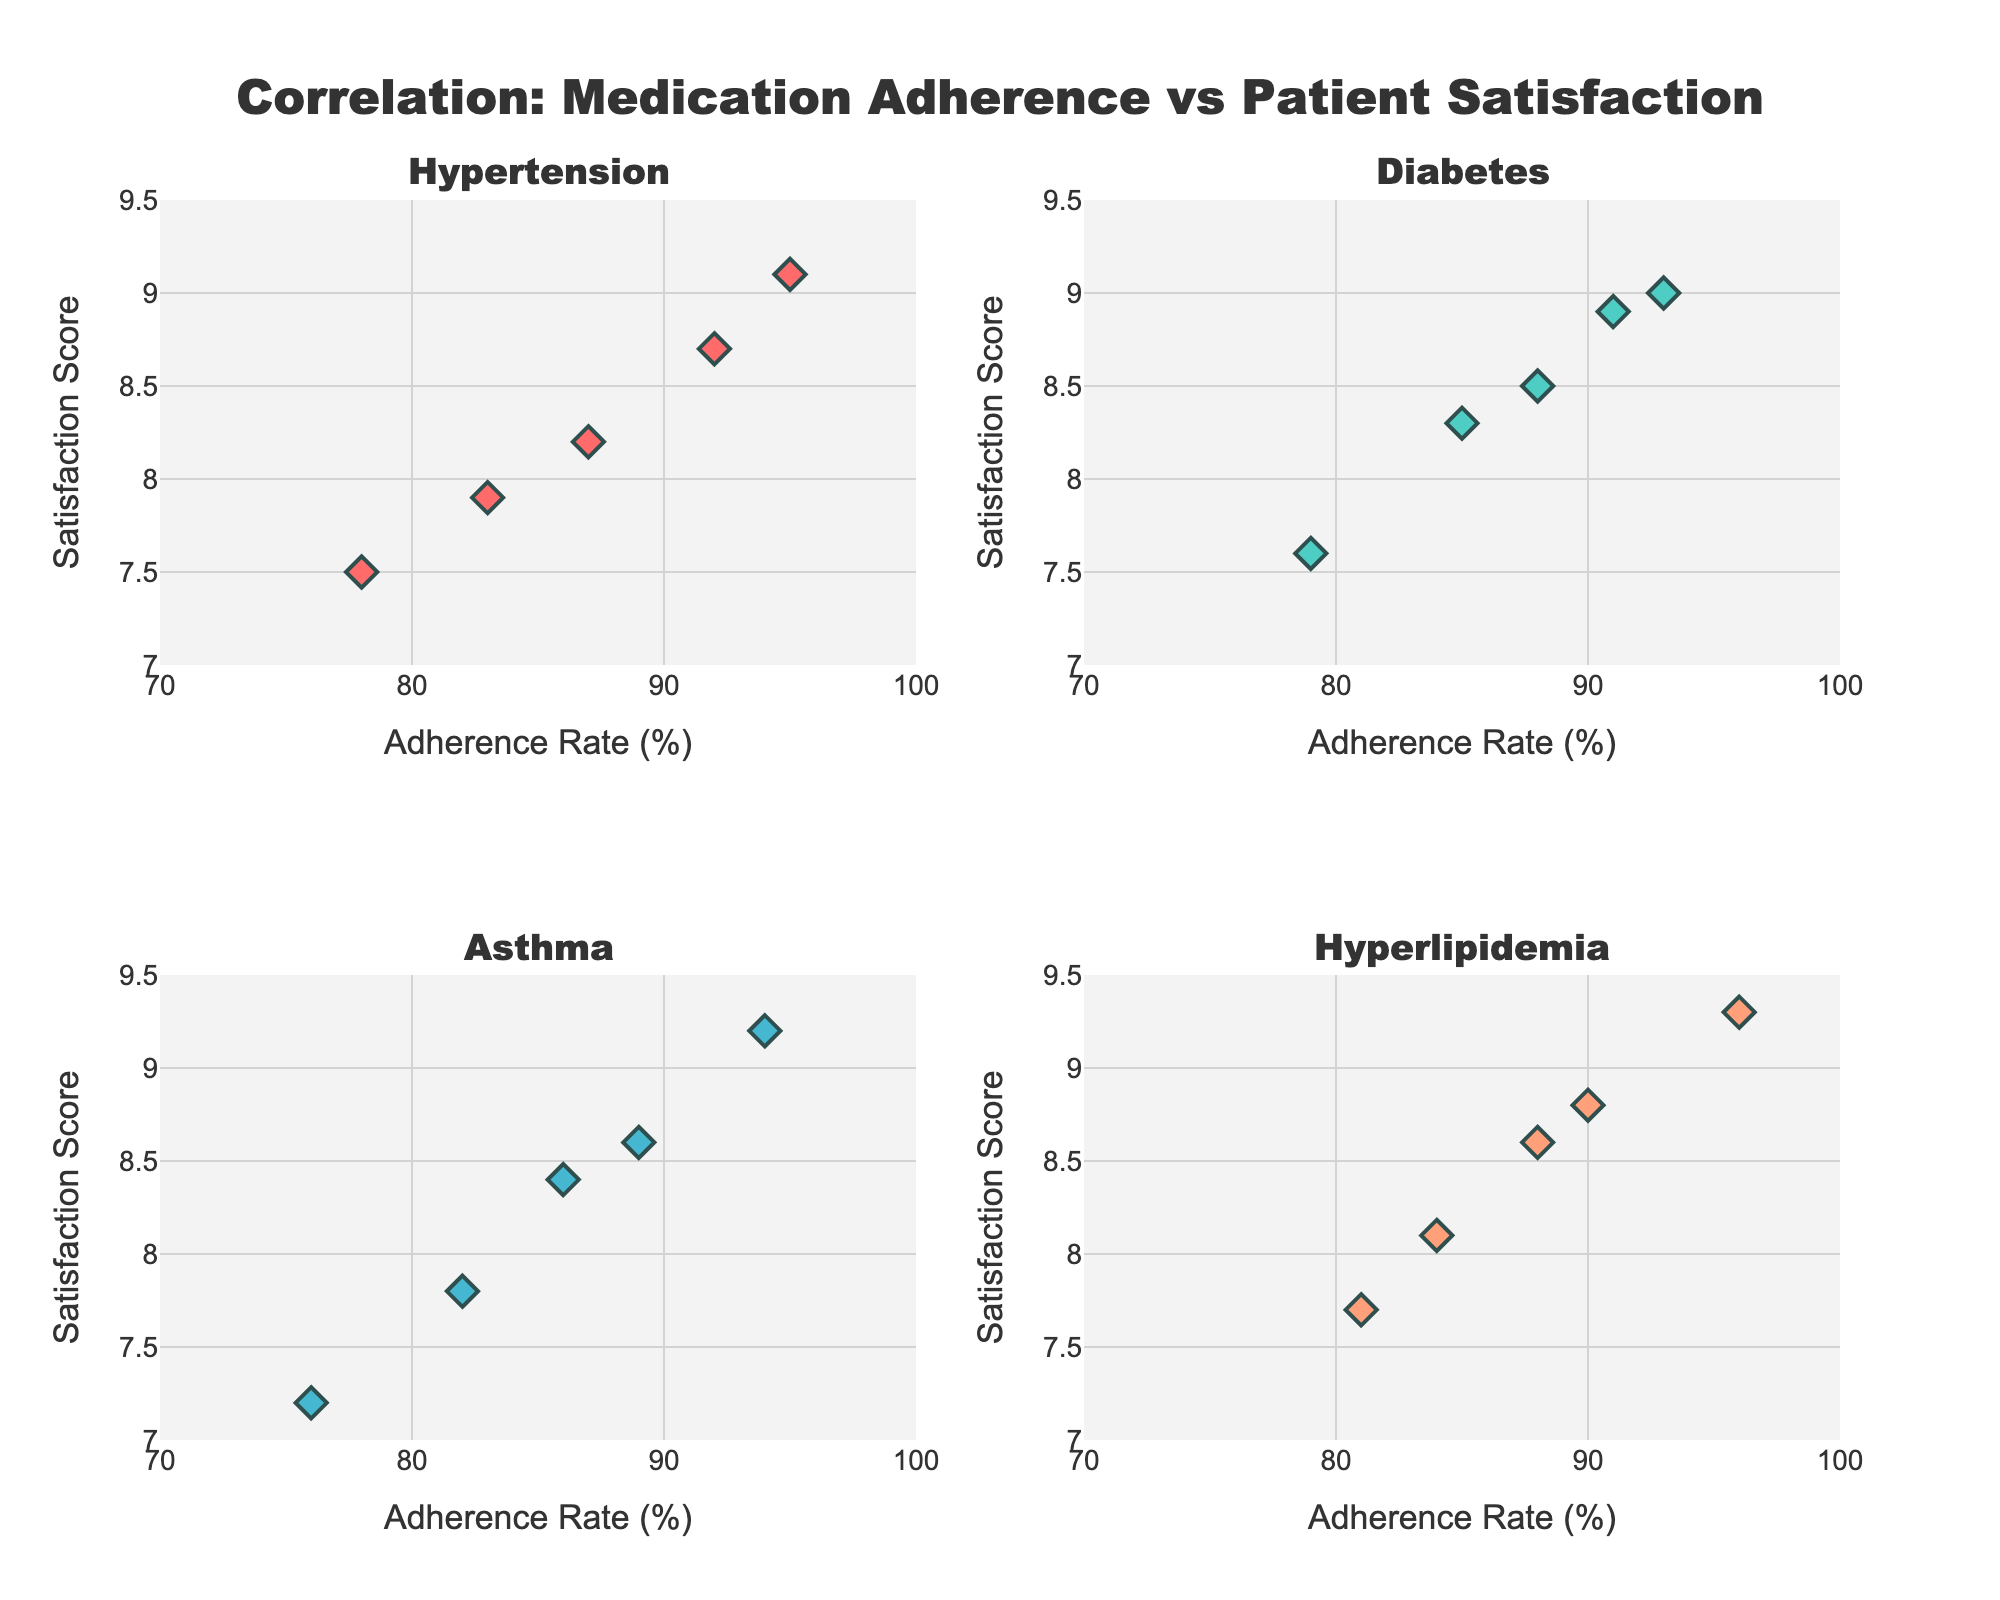What is the title of the figure? The title of the figure is displayed at the top center in large font. It reads "Correlation: Medication Adherence vs Patient Satisfaction".
Answer: Correlation: Medication Adherence vs Patient Satisfaction How many conditions are compared in the figure? The figure contains four subplot titles corresponding to the conditions being compared: Hypertension, Diabetes, Asthma, and Hyperlipidemia.
Answer: Four Which condition has the highest individual satisfaction score, and what is that score? From the subplots, the dot with the highest y-axis value (satisfaction score) is in the Asthma subplot, with a satisfaction score of 9.2.
Answer: Asthma, 9.2 What is the adherence rate for the data point with the lowest satisfaction score for Hypertension? The Hypertension subplot shows that the lowest satisfaction score is 7.5, corresponding to an adherence rate of 78%.
Answer: 78% What is the average satisfaction score for the Diabetes condition? For Diabetes, the satisfaction scores are 8.9, 8.3, 7.6, 8.5, 9.0. The average is calculated as (8.9 + 8.3 + 7.6 + 8.5 + 9.0) / 5 = 8.46.
Answer: 8.46 Which condition shows the widest range of adherence rates? By observing the x-axis range for each condition, Asthma shows the widest range from 76 to 94, a span of 18 points.
Answer: Asthma Compare the highest satisfaction score of Hypertension with that of Hyperlipidemia. Which one is higher and by how much? Hypertension’s highest score is 9.1, and Hyperlipidemia’s highest score is 9.3. Hyperlipidemia's highest score is higher by 0.2.
Answer: Hyperlipidemia, 0.2 What is the correlation trend between adherence rate and satisfaction score in the Diabetes condition? The scatter plot for Diabetes shows a positive trend where higher adherence rates generally correspond to higher satisfaction scores.
Answer: Positive trend Is there any overlap in satisfaction score ranges between Asthma and Hyperlipidemia? Asthma’s satisfaction scores range from about 7.2 to 9.2, and Hyperlipidemia’s range from about 7.7 to 9.3. There is an overlap between approximately 7.7 and 9.2.
Answer: Yes How does the satisfaction score vary with adherence in the Hypertension condition? In Hypertension, the scatter plot indicates that higher adherence rates are generally associated with higher satisfaction scores.
Answer: Higher adherence, higher satisfaction 